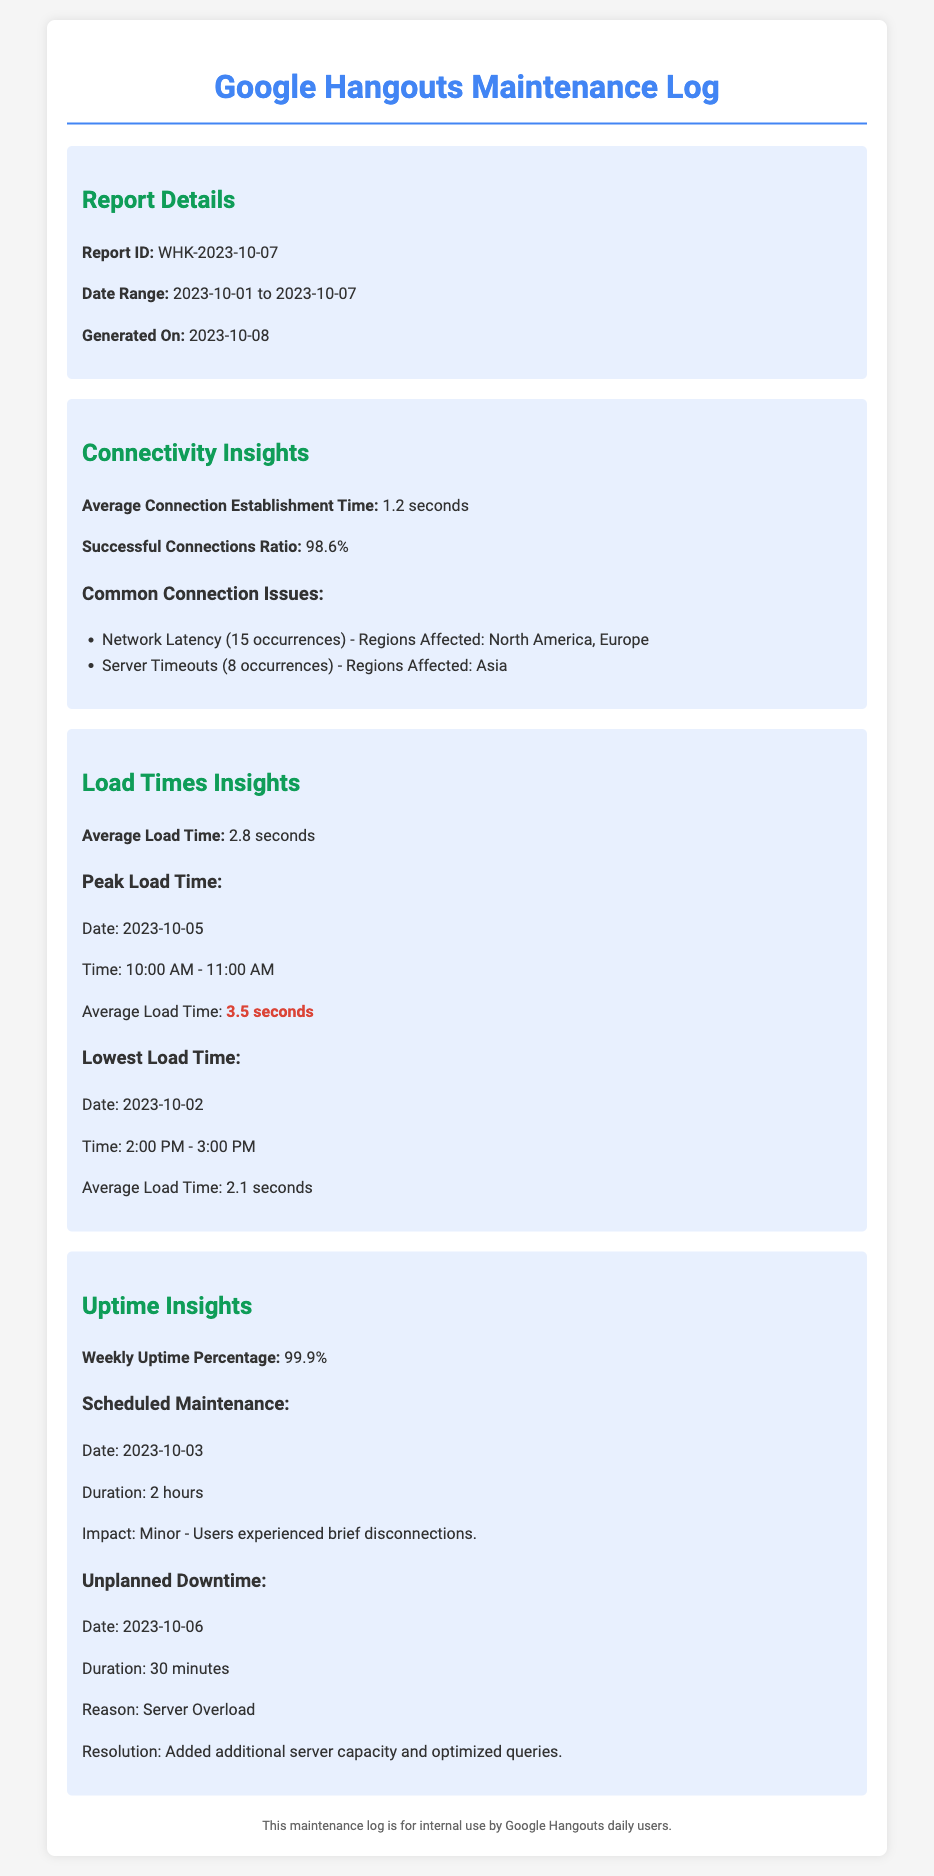What is the report ID? The report ID is stated at the beginning of the report details section.
Answer: WHK-2023-10-07 What is the average connection establishment time? The average connection establishment time is mentioned in the connectivity insights section.
Answer: 1.2 seconds How many occurrences of network latency were recorded? The count of occurrences for network latency is listed under common connection issues.
Answer: 15 What was the peak average load time? The peak load time is detailed in the load times insights section, including both date and time.
Answer: 3.5 seconds What was the duration of the scheduled maintenance? The duration of the scheduled maintenance is provided in the uptime insights section.
Answer: 2 hours What percentage of uptime was reported for the week? The weekly uptime percentage is reported in the uptime insights section.
Answer: 99.9% What was the reason for the unplanned downtime? The reason for the unplanned downtime is clearly stated in the report.
Answer: Server Overload On which date did the lowest load time occur? The date of the lowest load time is mentioned in the respective subsection.
Answer: 2023-10-02 What was the impact of the scheduled maintenance? The impact of the scheduled maintenance is described in the uptime insights section.
Answer: Minor - Users experienced brief disconnections 